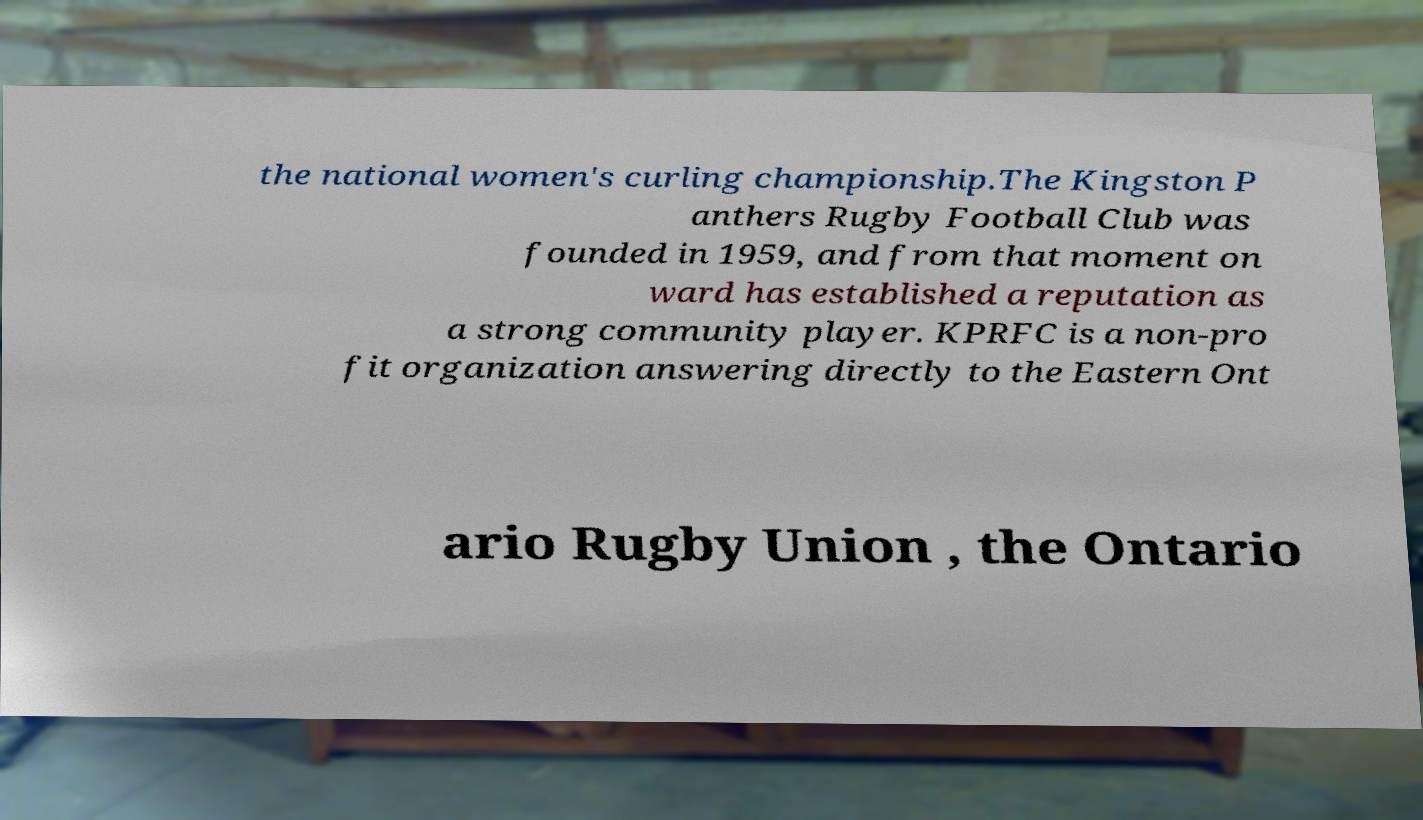What messages or text are displayed in this image? I need them in a readable, typed format. the national women's curling championship.The Kingston P anthers Rugby Football Club was founded in 1959, and from that moment on ward has established a reputation as a strong community player. KPRFC is a non-pro fit organization answering directly to the Eastern Ont ario Rugby Union , the Ontario 